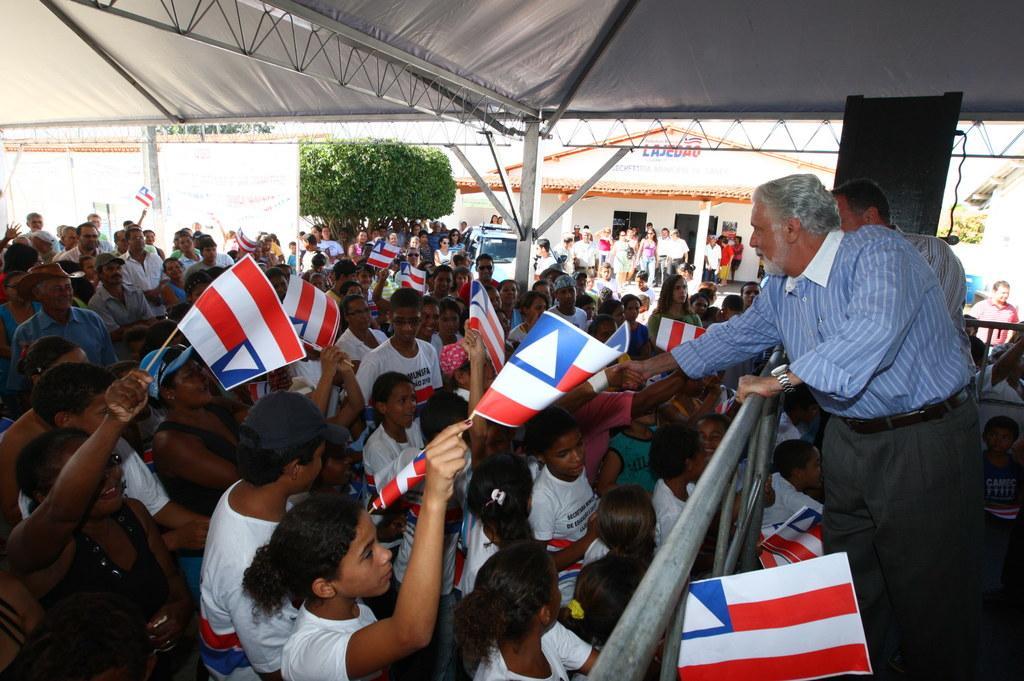Can you describe this image briefly? Here in this picture we can see number of children standing over a place and they are carrying flag posts in their hands and in front of them we can see a person standing and encouraging them and in between them we can see a railing present and at the top we can see a tent present and in the far we can see a store present and we can see plants present over there. 